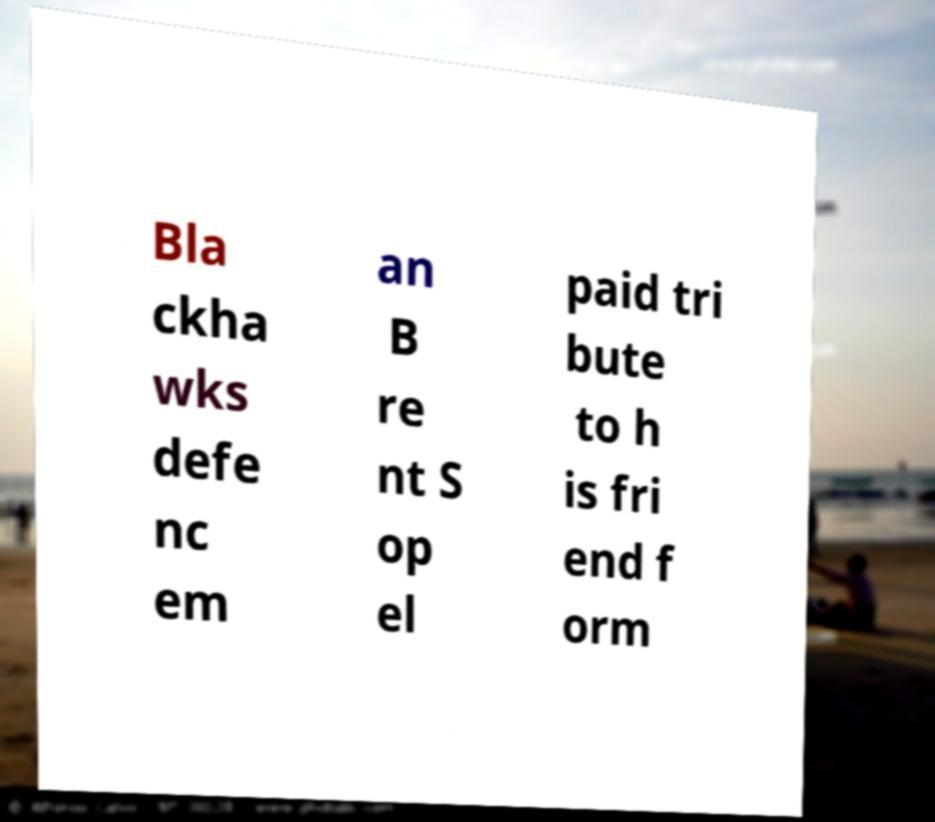Could you extract and type out the text from this image? Bla ckha wks defe nc em an B re nt S op el paid tri bute to h is fri end f orm 